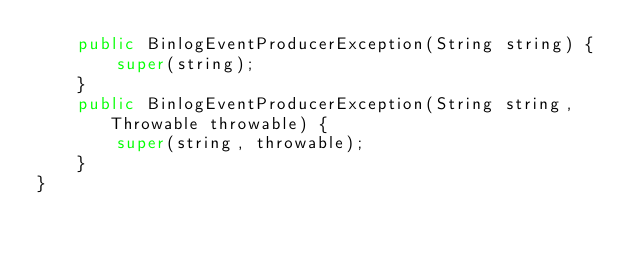Convert code to text. <code><loc_0><loc_0><loc_500><loc_500><_Java_>    public BinlogEventProducerException(String string) {
        super(string);
    }
    public BinlogEventProducerException(String string, Throwable throwable) {
        super(string, throwable);
    }
}
</code> 